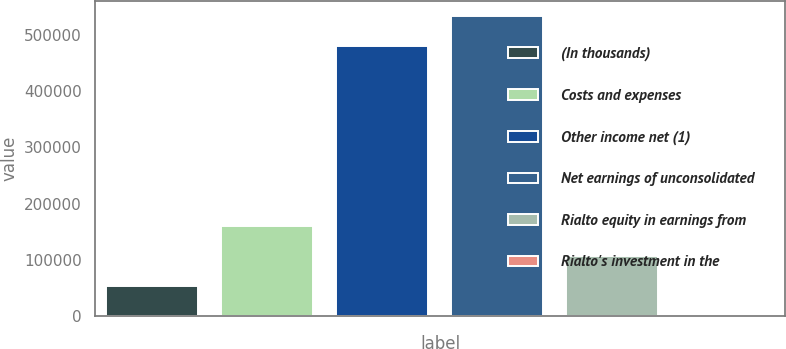Convert chart. <chart><loc_0><loc_0><loc_500><loc_500><bar_chart><fcel>(In thousands)<fcel>Costs and expenses<fcel>Other income net (1)<fcel>Net earnings of unconsolidated<fcel>Rialto equity in earnings from<fcel>Rialto's investment in the<nl><fcel>53484.2<fcel>160433<fcel>479929<fcel>534752<fcel>106958<fcel>10<nl></chart> 